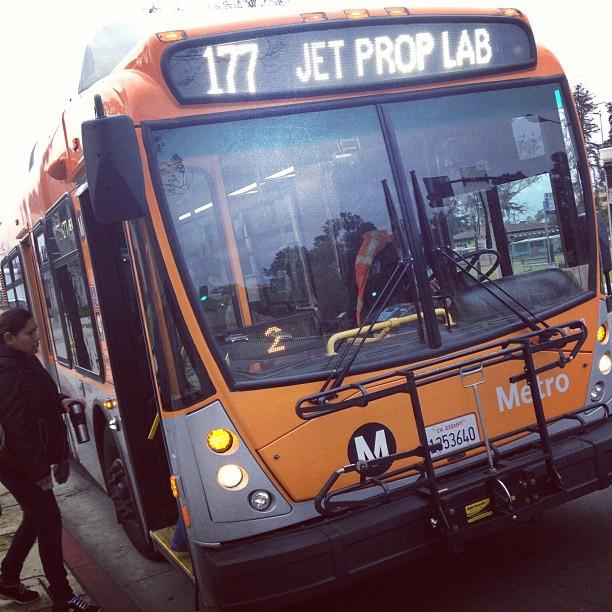What color is the bus?
Be succinct. Orange. What bus line is this?
Give a very brief answer. Metro. Is the lady getting on or off the bus?
Write a very short answer. On. 